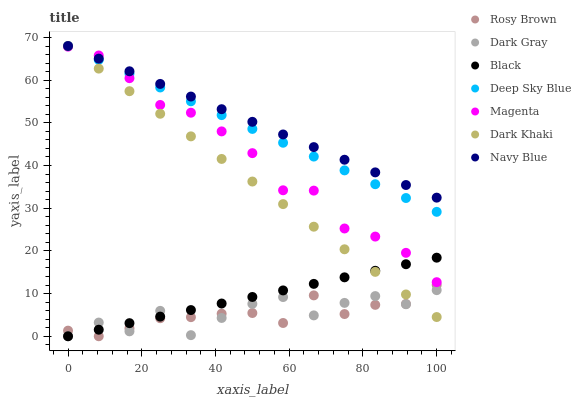Does Rosy Brown have the minimum area under the curve?
Answer yes or no. Yes. Does Navy Blue have the maximum area under the curve?
Answer yes or no. Yes. Does Navy Blue have the minimum area under the curve?
Answer yes or no. No. Does Rosy Brown have the maximum area under the curve?
Answer yes or no. No. Is Black the smoothest?
Answer yes or no. Yes. Is Dark Gray the roughest?
Answer yes or no. Yes. Is Navy Blue the smoothest?
Answer yes or no. No. Is Navy Blue the roughest?
Answer yes or no. No. Does Rosy Brown have the lowest value?
Answer yes or no. Yes. Does Navy Blue have the lowest value?
Answer yes or no. No. Does Deep Sky Blue have the highest value?
Answer yes or no. Yes. Does Rosy Brown have the highest value?
Answer yes or no. No. Is Rosy Brown less than Deep Sky Blue?
Answer yes or no. Yes. Is Deep Sky Blue greater than Black?
Answer yes or no. Yes. Does Deep Sky Blue intersect Navy Blue?
Answer yes or no. Yes. Is Deep Sky Blue less than Navy Blue?
Answer yes or no. No. Is Deep Sky Blue greater than Navy Blue?
Answer yes or no. No. Does Rosy Brown intersect Deep Sky Blue?
Answer yes or no. No. 